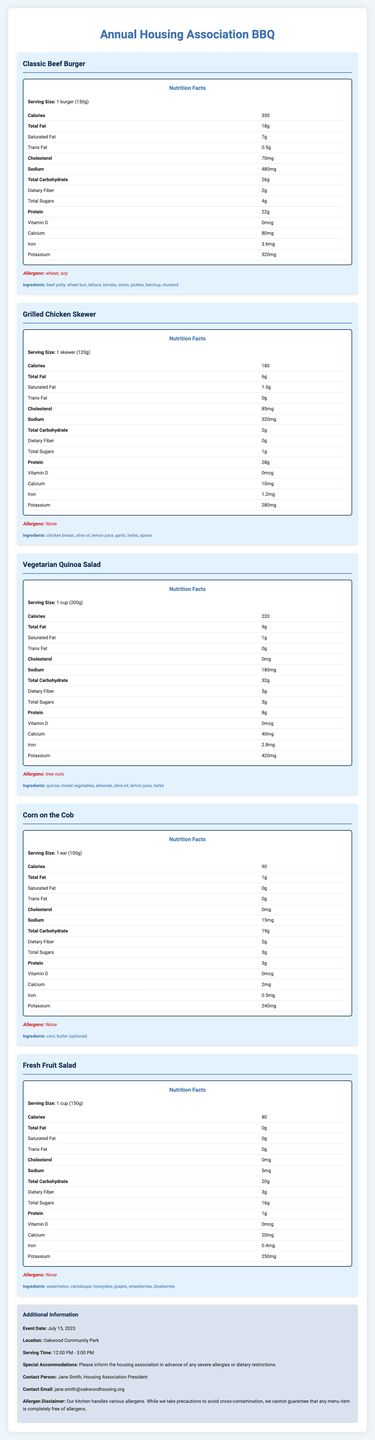how many calories are in the Classic Beef Burger? According to the nutrition facts, the Classic Beef Burger contains 350 calories.
Answer: 350 what are the allergens in the Vegetarian Quinoa Salad? The allergens listed for the Vegetarian Quinoa Salad are tree nuts.
Answer: tree nuts what is the serving size for the Corn on the Cob? The serving size for Corn on the Cob is 1 ear, which weighs 100 grams.
Answer: 1 ear (100g) who should you contact in case of severe allergies? The additional information section specifies that Jane Smith is the contact person for severe allergies or dietary restrictions.
Answer: Jane Smith, Housing Association President which menu item has the highest protein content? The Grilled Chicken Skewer has the highest protein content at 28 grams.
Answer: Grilled Chicken Skewer which menu item contains the most dietary fiber? A. Classic Beef Burger B. Grilled Chicken Skewer C. Vegetarian Quinoa Salad D. Corn on the Cob The Vegetarian Quinoa Salad contains the most dietary fiber at 5 grams.
Answer: C. Vegetarian Quinoa Salad which of these menu items contains soy? I. Classic Beef Burger II. Grilled Chicken Skewer III. Vegetarian Quinoa Salad IV. Fresh Fruit Salad The Classic Beef Burger contains soy, as listed in the allergen section.
Answer: I. Classic Beef Burger are there any allergens in the Fresh Fruit Salad? The Fresh Fruit Salad has no allergens listed in the document.
Answer: No is the Corn on the Cob high in sodium? The Corn on the Cob has 15mg of sodium, which is relatively low.
Answer: No describe the main idea of the document. The document lays out detailed nutritional information, ingredients, and allergens for each food item available at the BBQ event, while also providing logistical information about the event and contact details for addressing allergies or dietary restrictions.
Answer: This document provides nutrition facts and allergen information for the annual housing association BBQ menu items, along with event details and contact information for special accommodations. what is the recipe for the Classic Beef Burger? While the document lists the ingredients of the Classic Beef Burger, it does not provide the recipe or preparation method.
Answer: Cannot be determined 